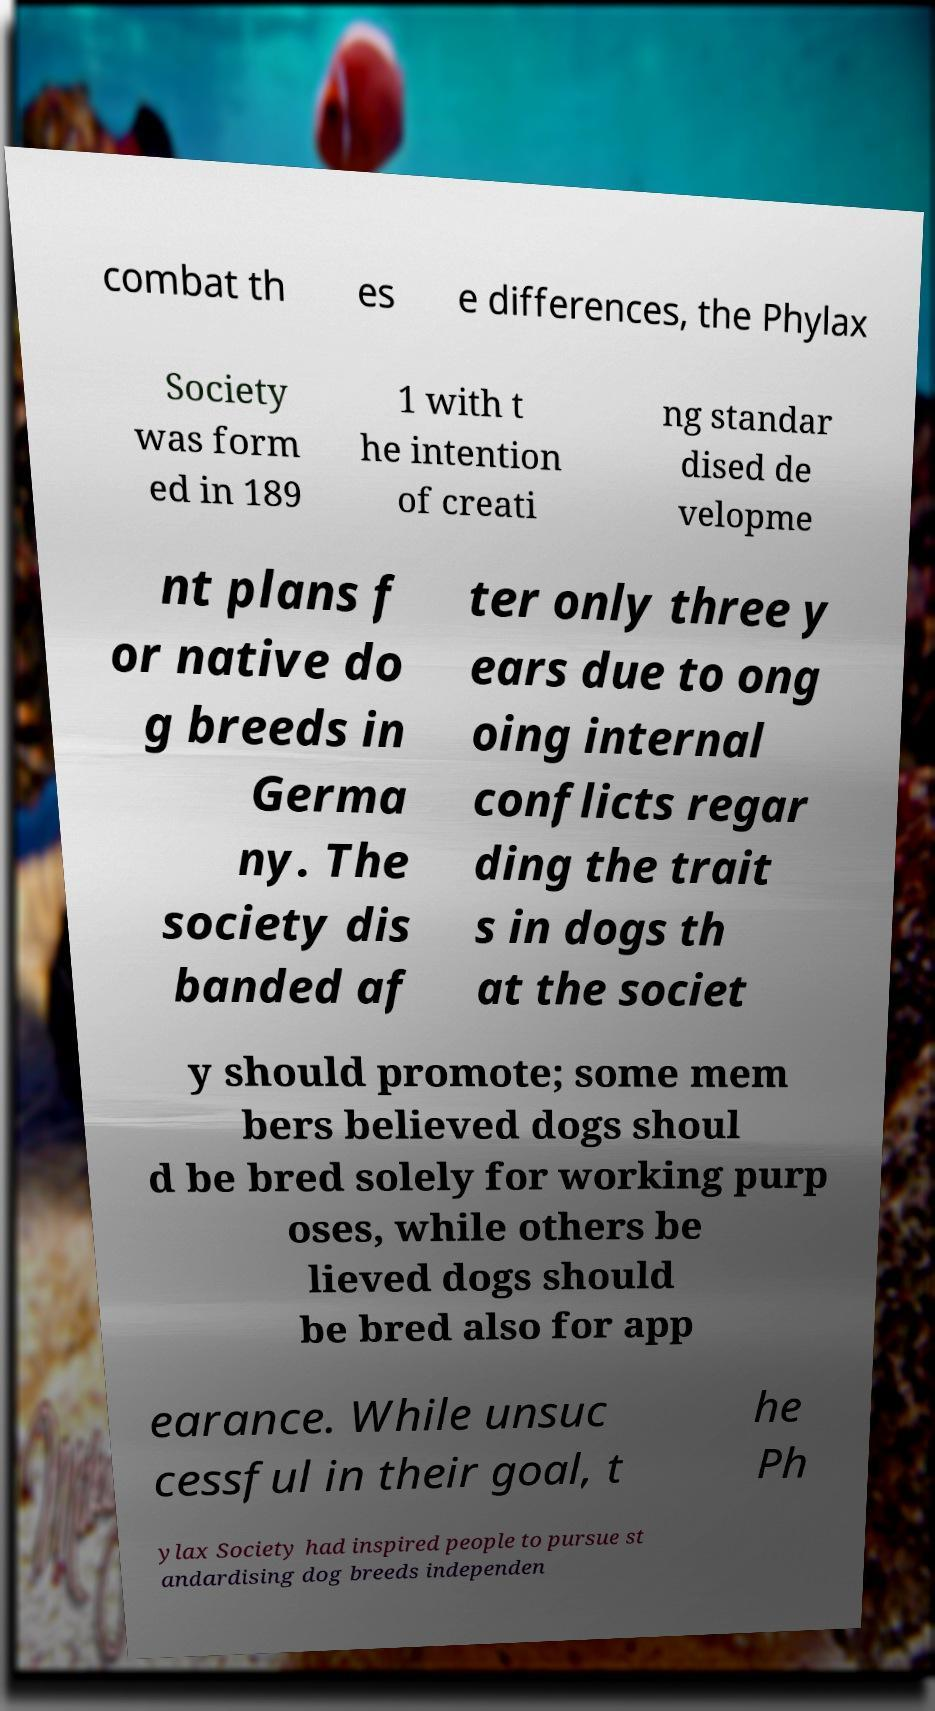Could you assist in decoding the text presented in this image and type it out clearly? combat th es e differences, the Phylax Society was form ed in 189 1 with t he intention of creati ng standar dised de velopme nt plans f or native do g breeds in Germa ny. The society dis banded af ter only three y ears due to ong oing internal conflicts regar ding the trait s in dogs th at the societ y should promote; some mem bers believed dogs shoul d be bred solely for working purp oses, while others be lieved dogs should be bred also for app earance. While unsuc cessful in their goal, t he Ph ylax Society had inspired people to pursue st andardising dog breeds independen 